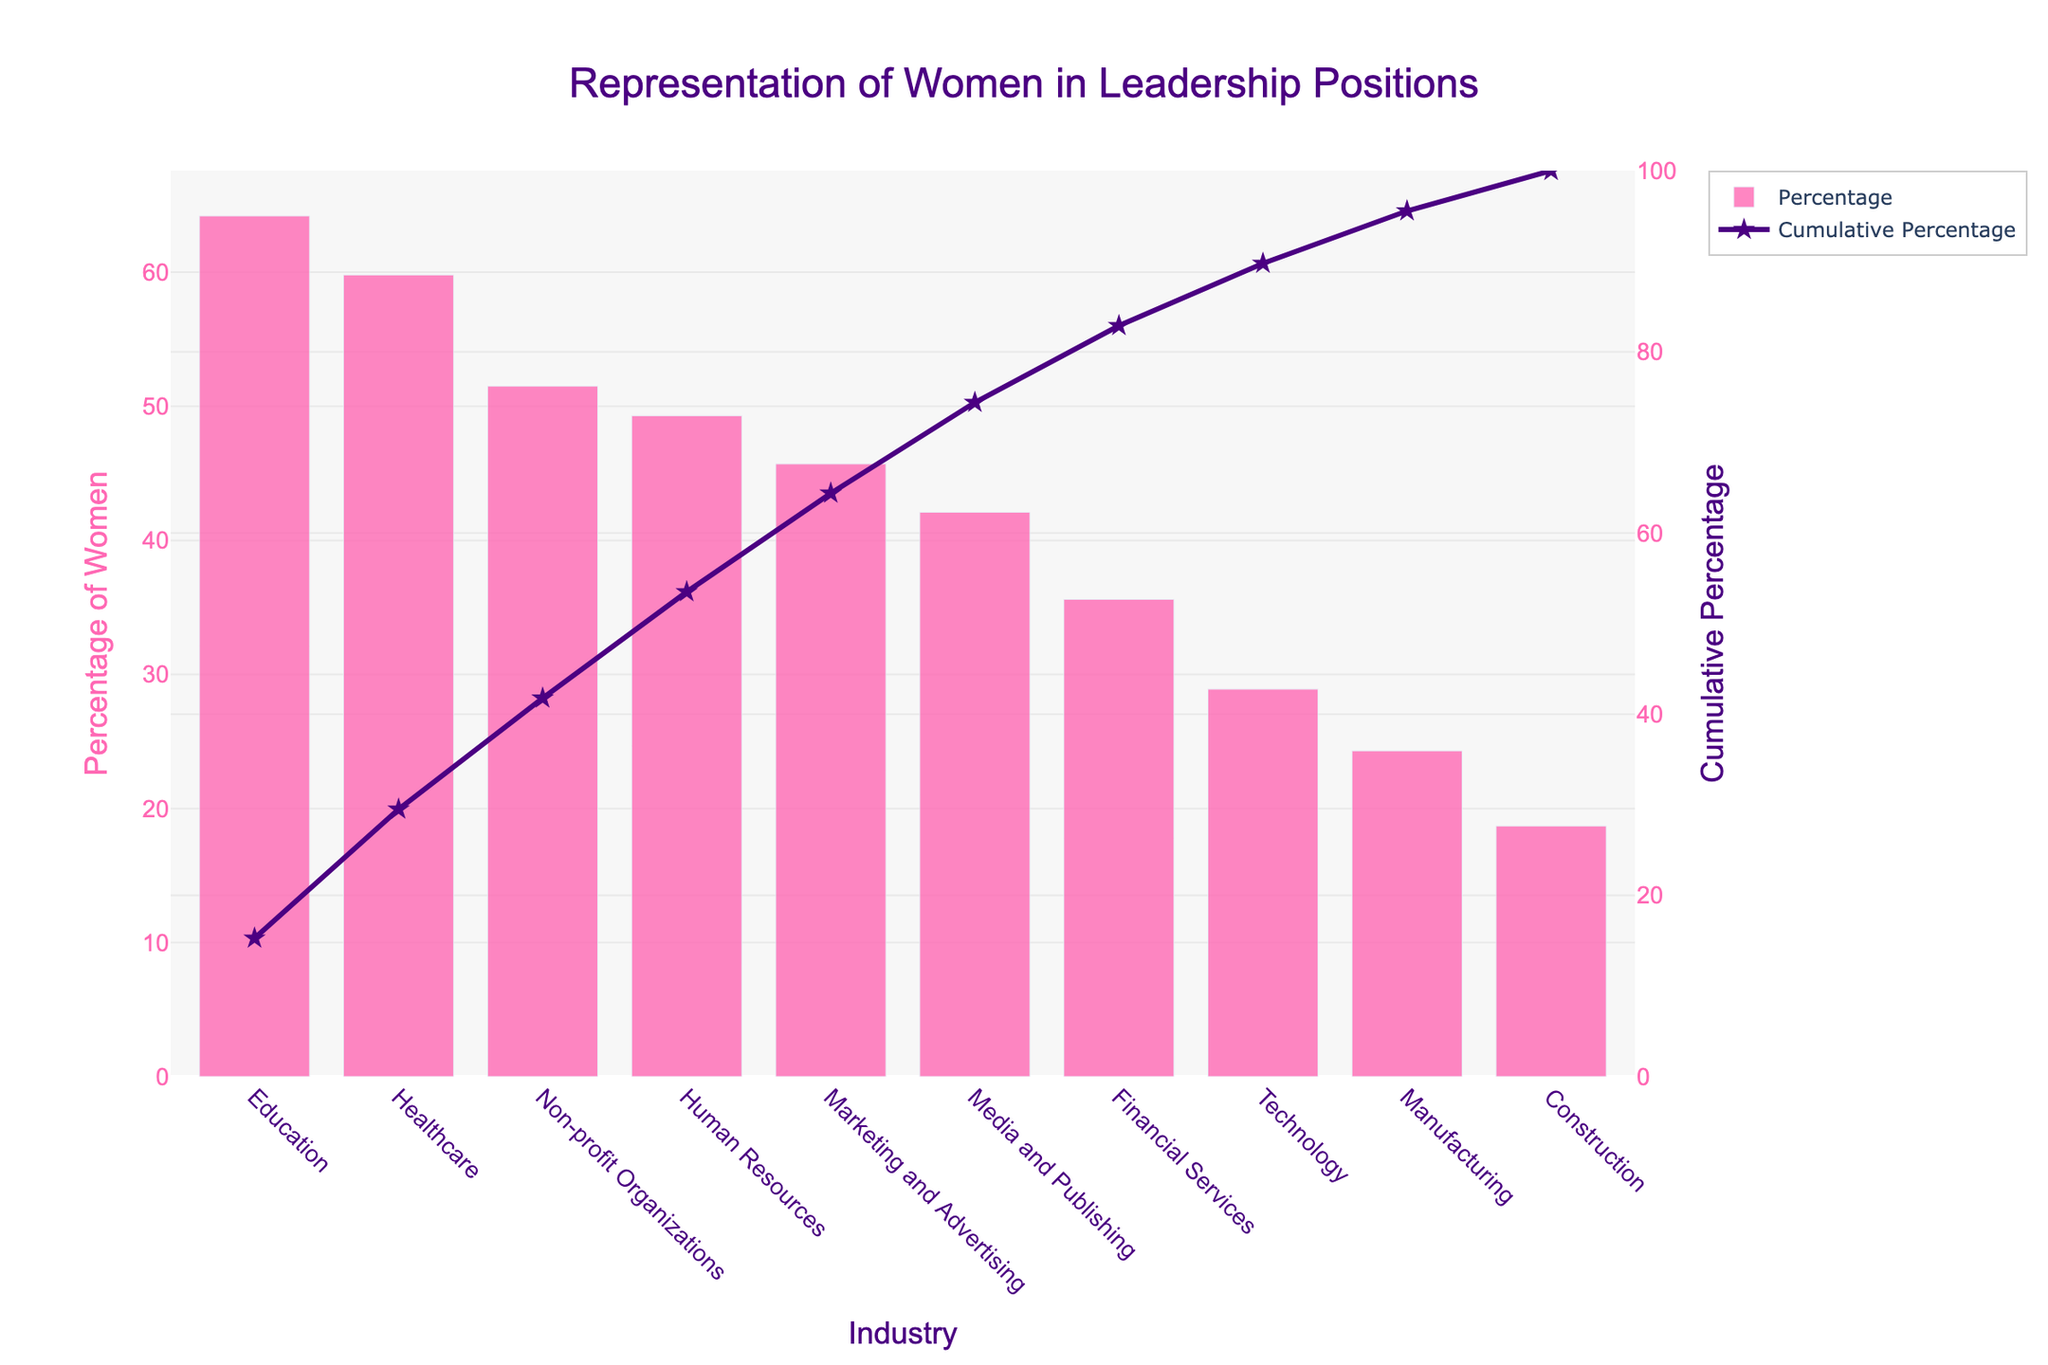What's the title of the chart? The title is the text displayed at the top of the chart, usually in a larger and bold font for visibility. In this case, it provides an overview of what the chart is about.
Answer: Representation of Women in Leadership Positions What industry has the highest percentage of women in leadership positions? This can be determined by looking at the bar with the highest value on the y-axis.
Answer: Education Which industry has the lowest percentage of women in leadership positions, and what is its percentage? Look for the bar with the smallest height on the y-axis and read its corresponding label on the x-axis.
Answer: Construction, 18.7% What's the cumulative percentage of women in leadership for the top three industries combined? To find this, sum the cumulative percentages of the top three industries from the chart.
Answer: 64.2 + 59.8 + 51.5 How many industries have more than 40% women in leadership positions? Count the number of bars where the percentage is greater than 40%.
Answer: Five Compare the percentage of women in leadership positions in Technology and Manufacturing. Which is higher? Identify the heights of the bars for Technology and Manufacturing and compare.
Answer: Technology What's the cumulative percentage after including the Healthcare industry? Locate the cumulative percentage value for Healthcare from the chart and report its value.
Answer: 124.0% What is the approximate cumulative percentage after the Media and Publishing industry? Add up the individual percentages of Education, Healthcare, Non-profit Organizations, Human Resources, Marketing and Advertising, and Media and Publishing, then normalize it over the total sum of all percentages.
Answer: Approximately 312.6% Why is there a secondary y-axis in this Pareto chart? The secondary y-axis represents the cumulative percentage, which gives additional information about the aggregated impact of the individual categories.
Answer: To show cumulative percentage How does the percentage of women in leadership in Financial Services compare to that in Human Resources? Look at the height of the bars for Financial Services and Human Resources, compare which one is taller.
Answer: Lower in Financial Services 